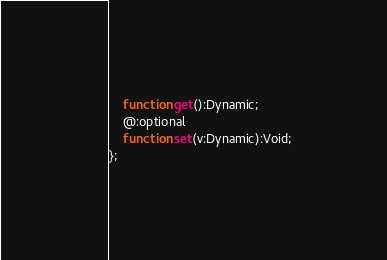<code> <loc_0><loc_0><loc_500><loc_500><_Haxe_>	function get():Dynamic;
	@:optional
	function set(v:Dynamic):Void;
};</code> 